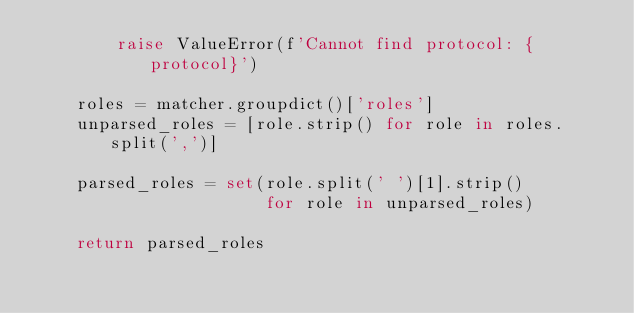<code> <loc_0><loc_0><loc_500><loc_500><_Python_>        raise ValueError(f'Cannot find protocol: {protocol}')

    roles = matcher.groupdict()['roles']
    unparsed_roles = [role.strip() for role in roles.split(',')]

    parsed_roles = set(role.split(' ')[1].strip()
                       for role in unparsed_roles)

    return parsed_roles
</code> 